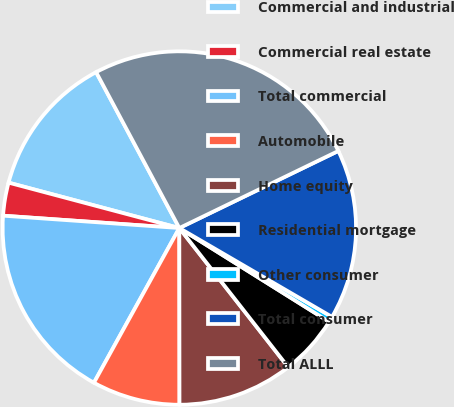Convert chart to OTSL. <chart><loc_0><loc_0><loc_500><loc_500><pie_chart><fcel>Commercial and industrial<fcel>Commercial real estate<fcel>Total commercial<fcel>Automobile<fcel>Home equity<fcel>Residential mortgage<fcel>Other consumer<fcel>Total consumer<fcel>Total ALLL<nl><fcel>13.06%<fcel>3.02%<fcel>18.08%<fcel>8.04%<fcel>10.55%<fcel>5.53%<fcel>0.51%<fcel>15.57%<fcel>25.61%<nl></chart> 